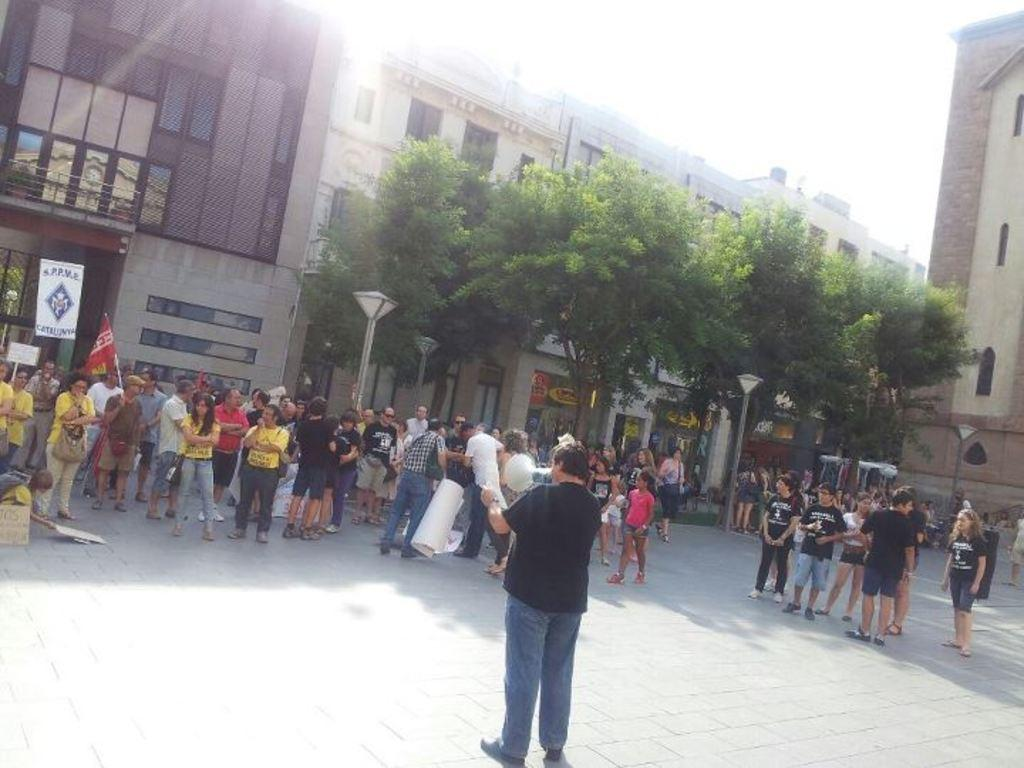What is the main subject in the foreground of the image? There is a crowd in the foreground of the image. What is placed on the road in the foreground? There are boards on the road in the foreground. What can be seen in the background of the image? There are light poles, trees, buildings, windows, and the sky visible in the background of the image. What is the weather like in the image? The image was taken during a sunny day. What type of leather is being used to cover the donkey in the image? There is no donkey or leather present in the image. What kind of system is being used to organize the crowd in the image? There is no system mentioned or visible in the image for organizing the crowd. 